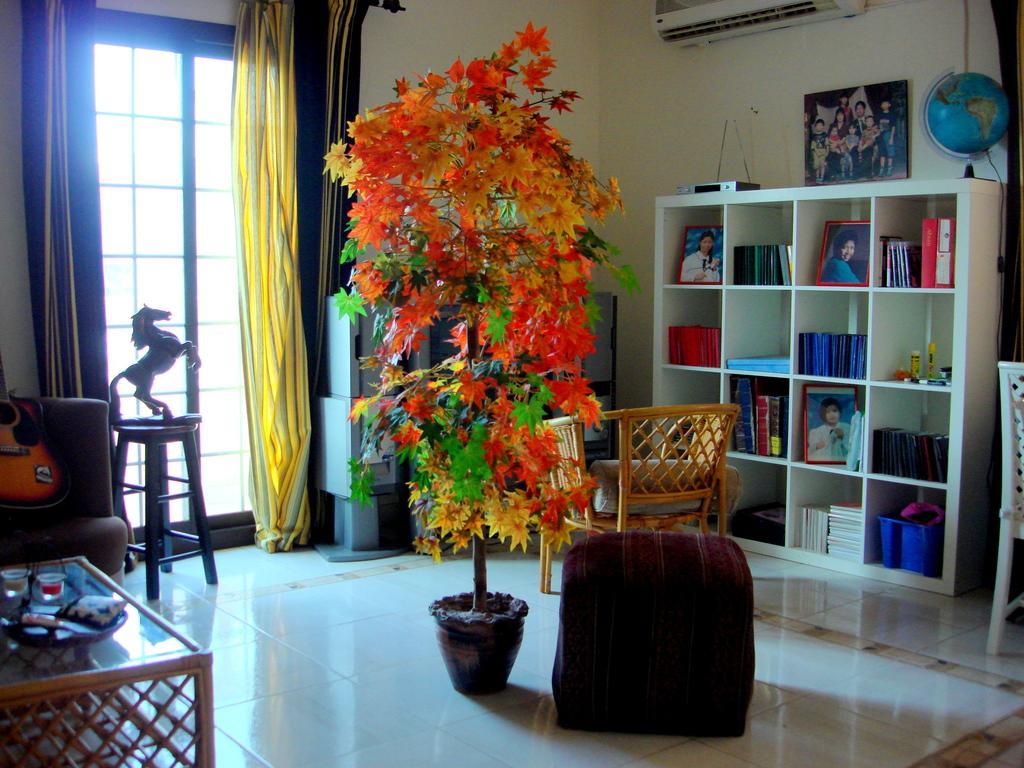Describe this image in one or two sentences. This is the inside view of a room where we can see a plant, table, sofa, guitar, stool, statue, chairs and the floor. On the right side of the image, we can see so many books and photographs are arranged on shelves. At the top of the image, we can see AC and a photo frame on the wall. In the background, we can see a door, curtains and some objects. On the table, we can see glasses and some objects. 